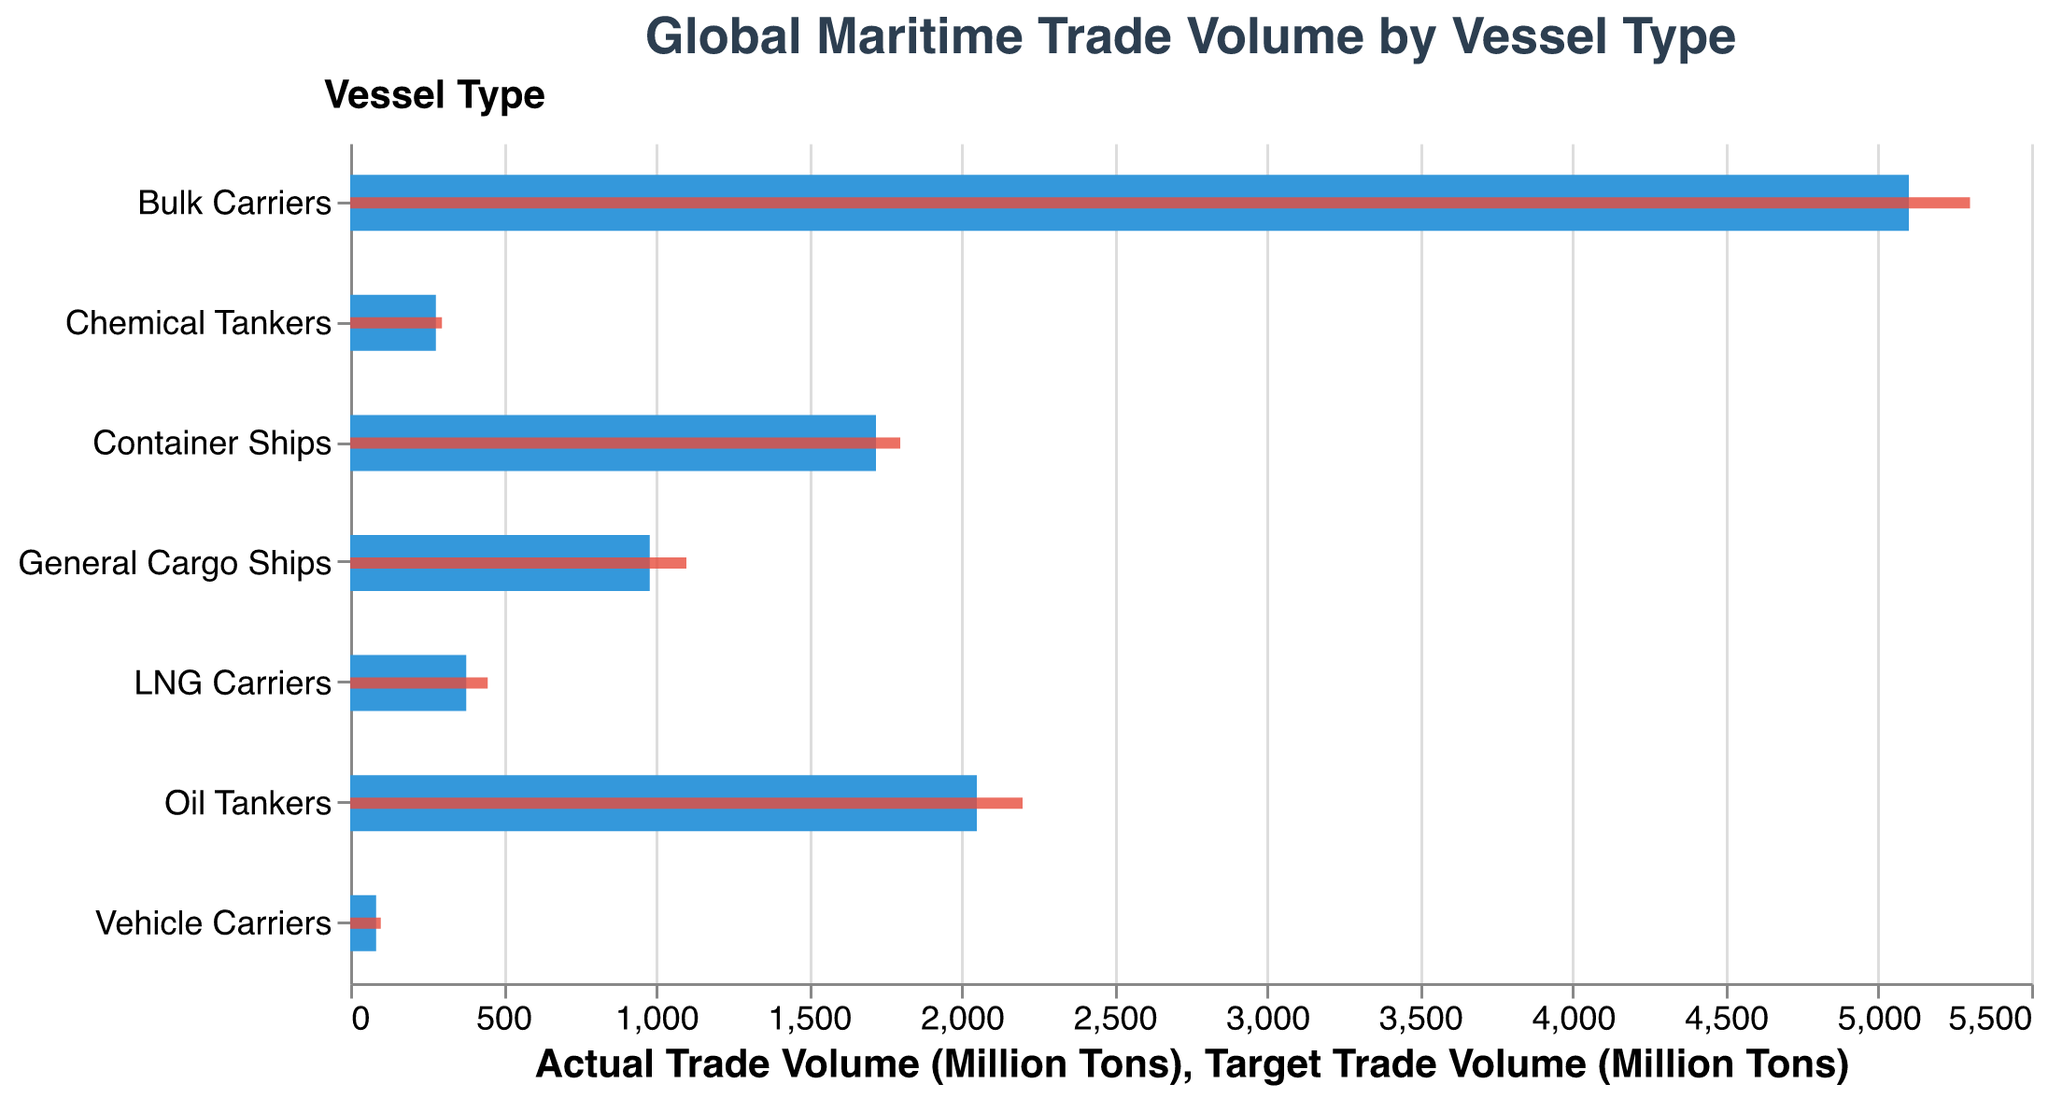What is the title of the figure? The title text is located at the top of the figure in larger font and reads "Global Maritime Trade Volume by Vessel Type".
Answer: Global Maritime Trade Volume by Vessel Type What are the colors used for the actual and target trade volumes? The colors for the bars indicating actual trade volumes are blue, while the bars indicating the target trade volumes are red.
Answer: Blue and Red Which vessel type has the highest actual trade volume? The bar for Bulk Carriers extends the farthest to the right, indicating the highest actual trade volume in the figure.
Answer: Bulk Carriers Which vessel type has the smallest discrepancy between actual and target trade volumes? The discrepancy can be visually estimated by comparing the lengths of the blue and red bars for each vessel type. Container Ships have the smallest difference of 80 million tons between actual (1720) and target (1800) trade volumes.
Answer: Container Ships What is the average actual trade volume across all vessel types? Sum all actual trade volumes: 1720 + 2050 + 5100 + 380 + 980 + 280 + 85 = 10595 million tons. Then, divide by the number of vessel types: 10595 / 7 ≈ 1513.57 million tons.
Answer: 1513.57 million tons How much higher is the target trade volume for LNG Carriers compared to the actual trade volume? Subtract the actual trade volume of LNG Carriers from their target trade volume: 450 - 380 = 70 million tons.
Answer: 70 million tons Which vessel type has the largest discrepancy between actual and target trade volumes? Compare the discrepancies (Target - Actual) across all vessel types; General Cargo Ships have the largest difference of 120 million tons (1100 - 980).
Answer: General Cargo Ships For which vessel types do the actual trade volumes exceed 1000 million tons? The figures for Bulk Carriers (5100), Oil Tankers (2050), and Container Ships (1720) exceed 1000 million tons.
Answer: Bulk Carriers, Oil Tankers, Container Ships Is there any vessel type where the actual trade volume exceeds the target trade volume? By comparing the lengths of blue and red bars, none of the vessel types show the actual trade volume exceeding the target trade volume.
Answer: No By how much does the actual trade volume of Chemical Tankers fall short of the target trade volume? Subtract the actual trade volume of Chemical Tankers from their target trade volume: 300 - 280 = 20 million tons.
Answer: 20 million tons 